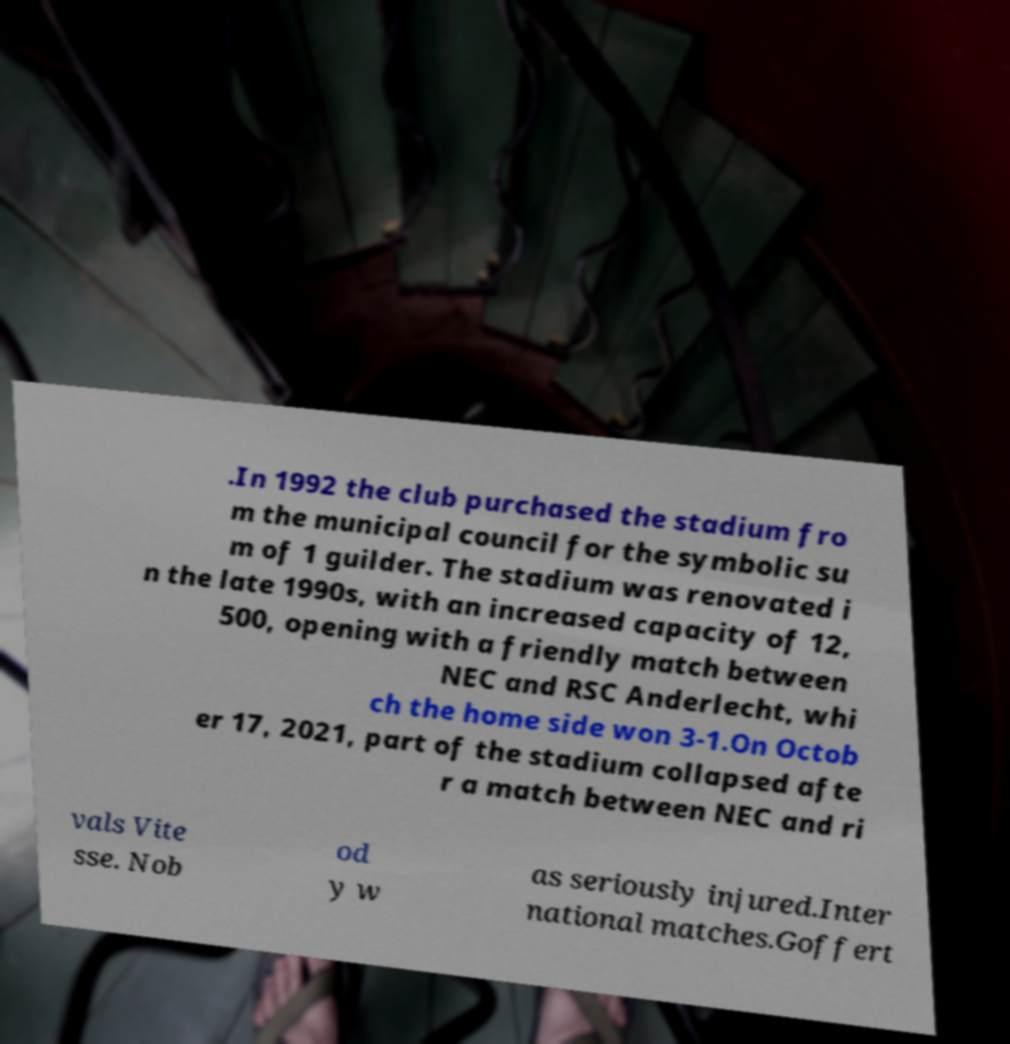There's text embedded in this image that I need extracted. Can you transcribe it verbatim? .In 1992 the club purchased the stadium fro m the municipal council for the symbolic su m of 1 guilder. The stadium was renovated i n the late 1990s, with an increased capacity of 12, 500, opening with a friendly match between NEC and RSC Anderlecht, whi ch the home side won 3-1.On Octob er 17, 2021, part of the stadium collapsed afte r a match between NEC and ri vals Vite sse. Nob od y w as seriously injured.Inter national matches.Goffert 